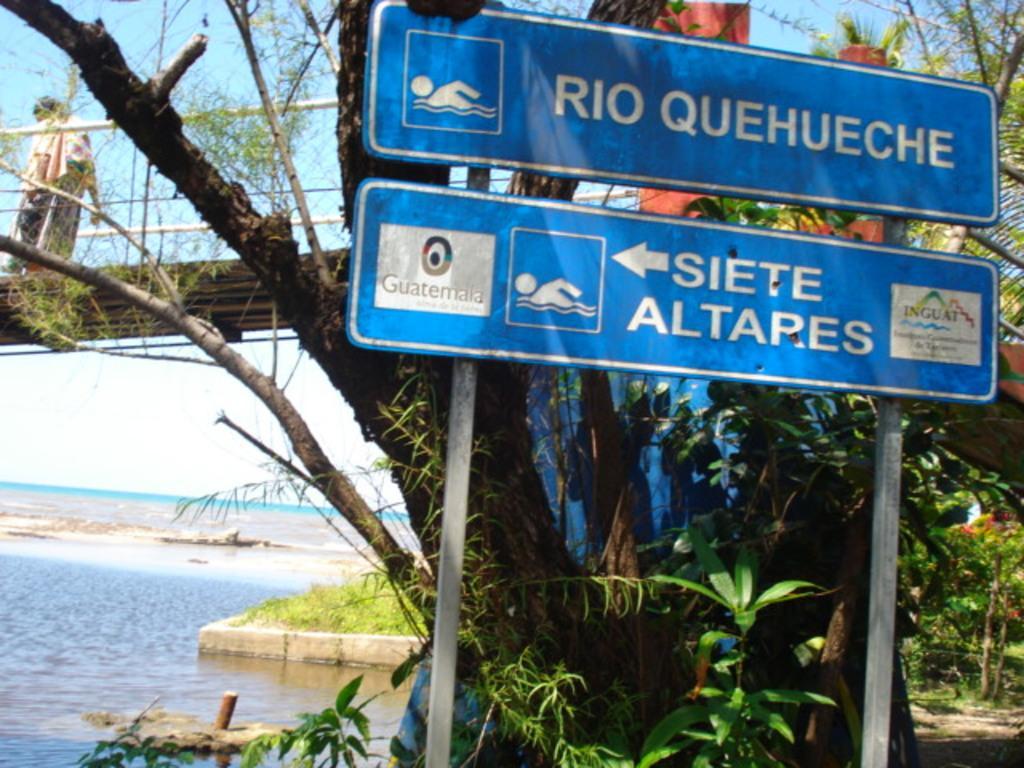How would you summarize this image in a sentence or two? In the foreground I can see a board, plants, trees. In the background I can see water, grass, bridge and a person. On the top I can see the sky. This image is taken may be near the river. 